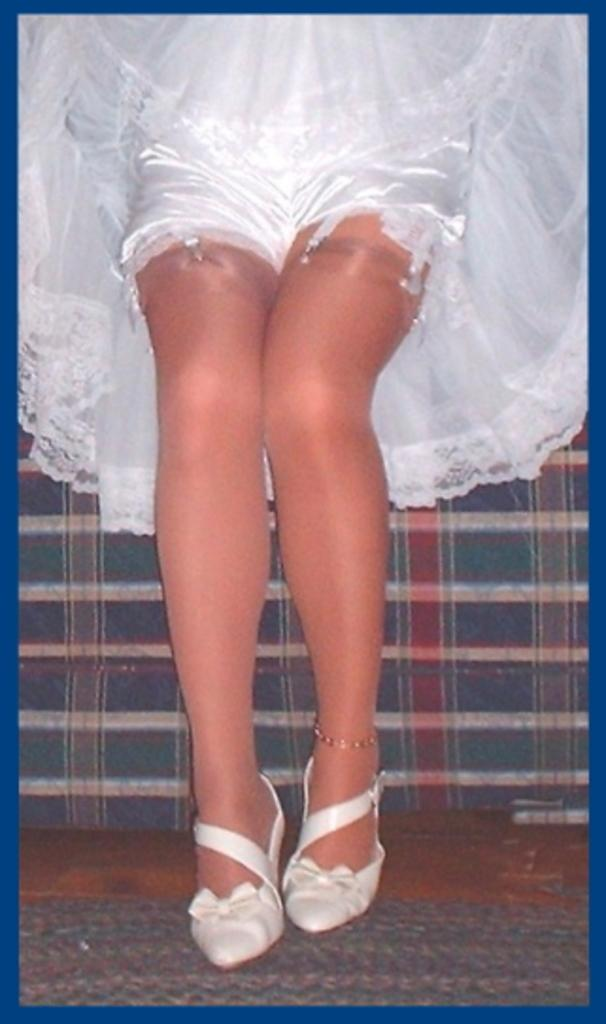What part of a woman can be seen in the image? There are legs of a woman in the image. What is the woman wearing in the image? The woman is wearing a white dress. Reasoning: Let' Let's think step by step in order to produce the conversation. We start by identifying the main subject in the image, which is the legs of a woman. Then, we expand the conversation to include the clothing of the woman, which is a white dress. Each question is designed to elicit a specific detail about the image that is known from the provided facts. Absurd Question/Answer: What type of vessel is the woman using to attack in the image? There is no vessel or attack present in the image; it only shows the legs of a woman wearing a white dress. What type of insurance does the woman have for her dress in the image? There is no information about insurance or the woman's dress in the image; it only shows the legs of a woman wearing a white dress. 